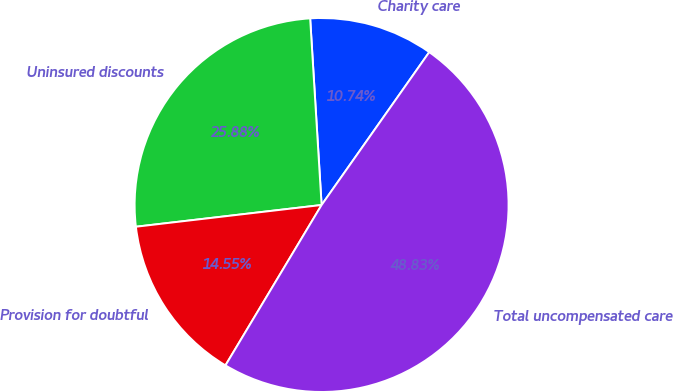Convert chart. <chart><loc_0><loc_0><loc_500><loc_500><pie_chart><fcel>Charity care<fcel>Uninsured discounts<fcel>Provision for doubtful<fcel>Total uncompensated care<nl><fcel>10.74%<fcel>25.88%<fcel>14.55%<fcel>48.83%<nl></chart> 